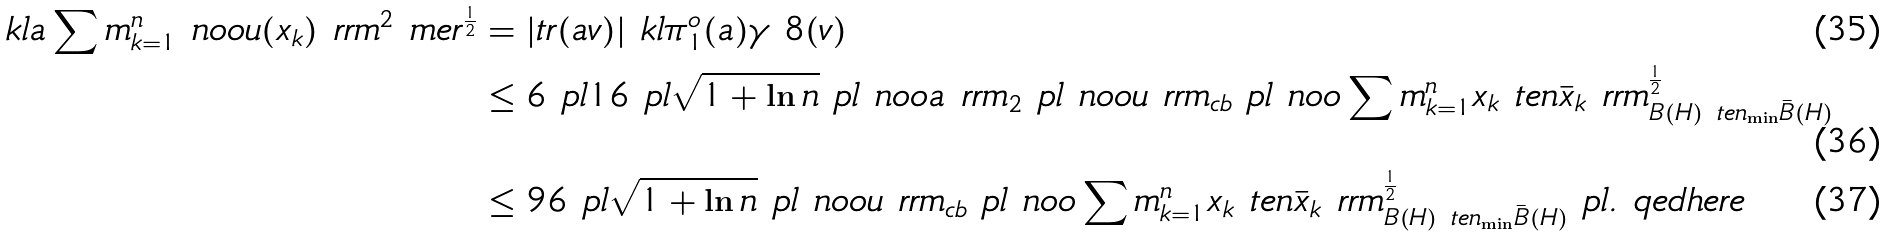<formula> <loc_0><loc_0><loc_500><loc_500>\ k l a \sum m _ { k = 1 } ^ { n } \ n o o u ( x _ { k } ) \ r r m ^ { 2 } \ m e r ^ { \frac { 1 } { 2 } } & = | t r ( a v ) | \ k l \pi _ { 1 } ^ { o } ( a ) \gamma _ { \ } 8 ( v ) \\ & \leq 6 \ p l 1 6 \ p l \sqrt { 1 + \ln n } \ p l \ n o o a \ r r m _ { 2 } \ p l \ n o o u \ r r m _ { c b } \ p l \ n o o \sum m _ { k = 1 } ^ { n } x _ { k } \ t e n \bar { x } _ { k } \ r r m _ { B ( H ) \ t e n _ { \min } \bar { B } ( H ) } ^ { \frac { 1 } { 2 } } \\ & \leq 9 6 \ p l \sqrt { 1 + \ln n } \ p l \ n o o u \ r r m _ { c b } \ p l \ n o o \sum m _ { k = 1 } ^ { n } x _ { k } \ t e n \bar { x } _ { k } \ r r m _ { B ( H ) \ t e n _ { \min } \bar { B } ( H ) } ^ { \frac { 1 } { 2 } } \ p l . \ q e d h e r e</formula> 